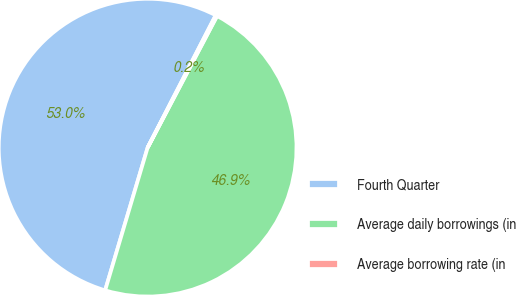Convert chart. <chart><loc_0><loc_0><loc_500><loc_500><pie_chart><fcel>Fourth Quarter<fcel>Average daily borrowings (in<fcel>Average borrowing rate (in<nl><fcel>52.96%<fcel>46.89%<fcel>0.16%<nl></chart> 